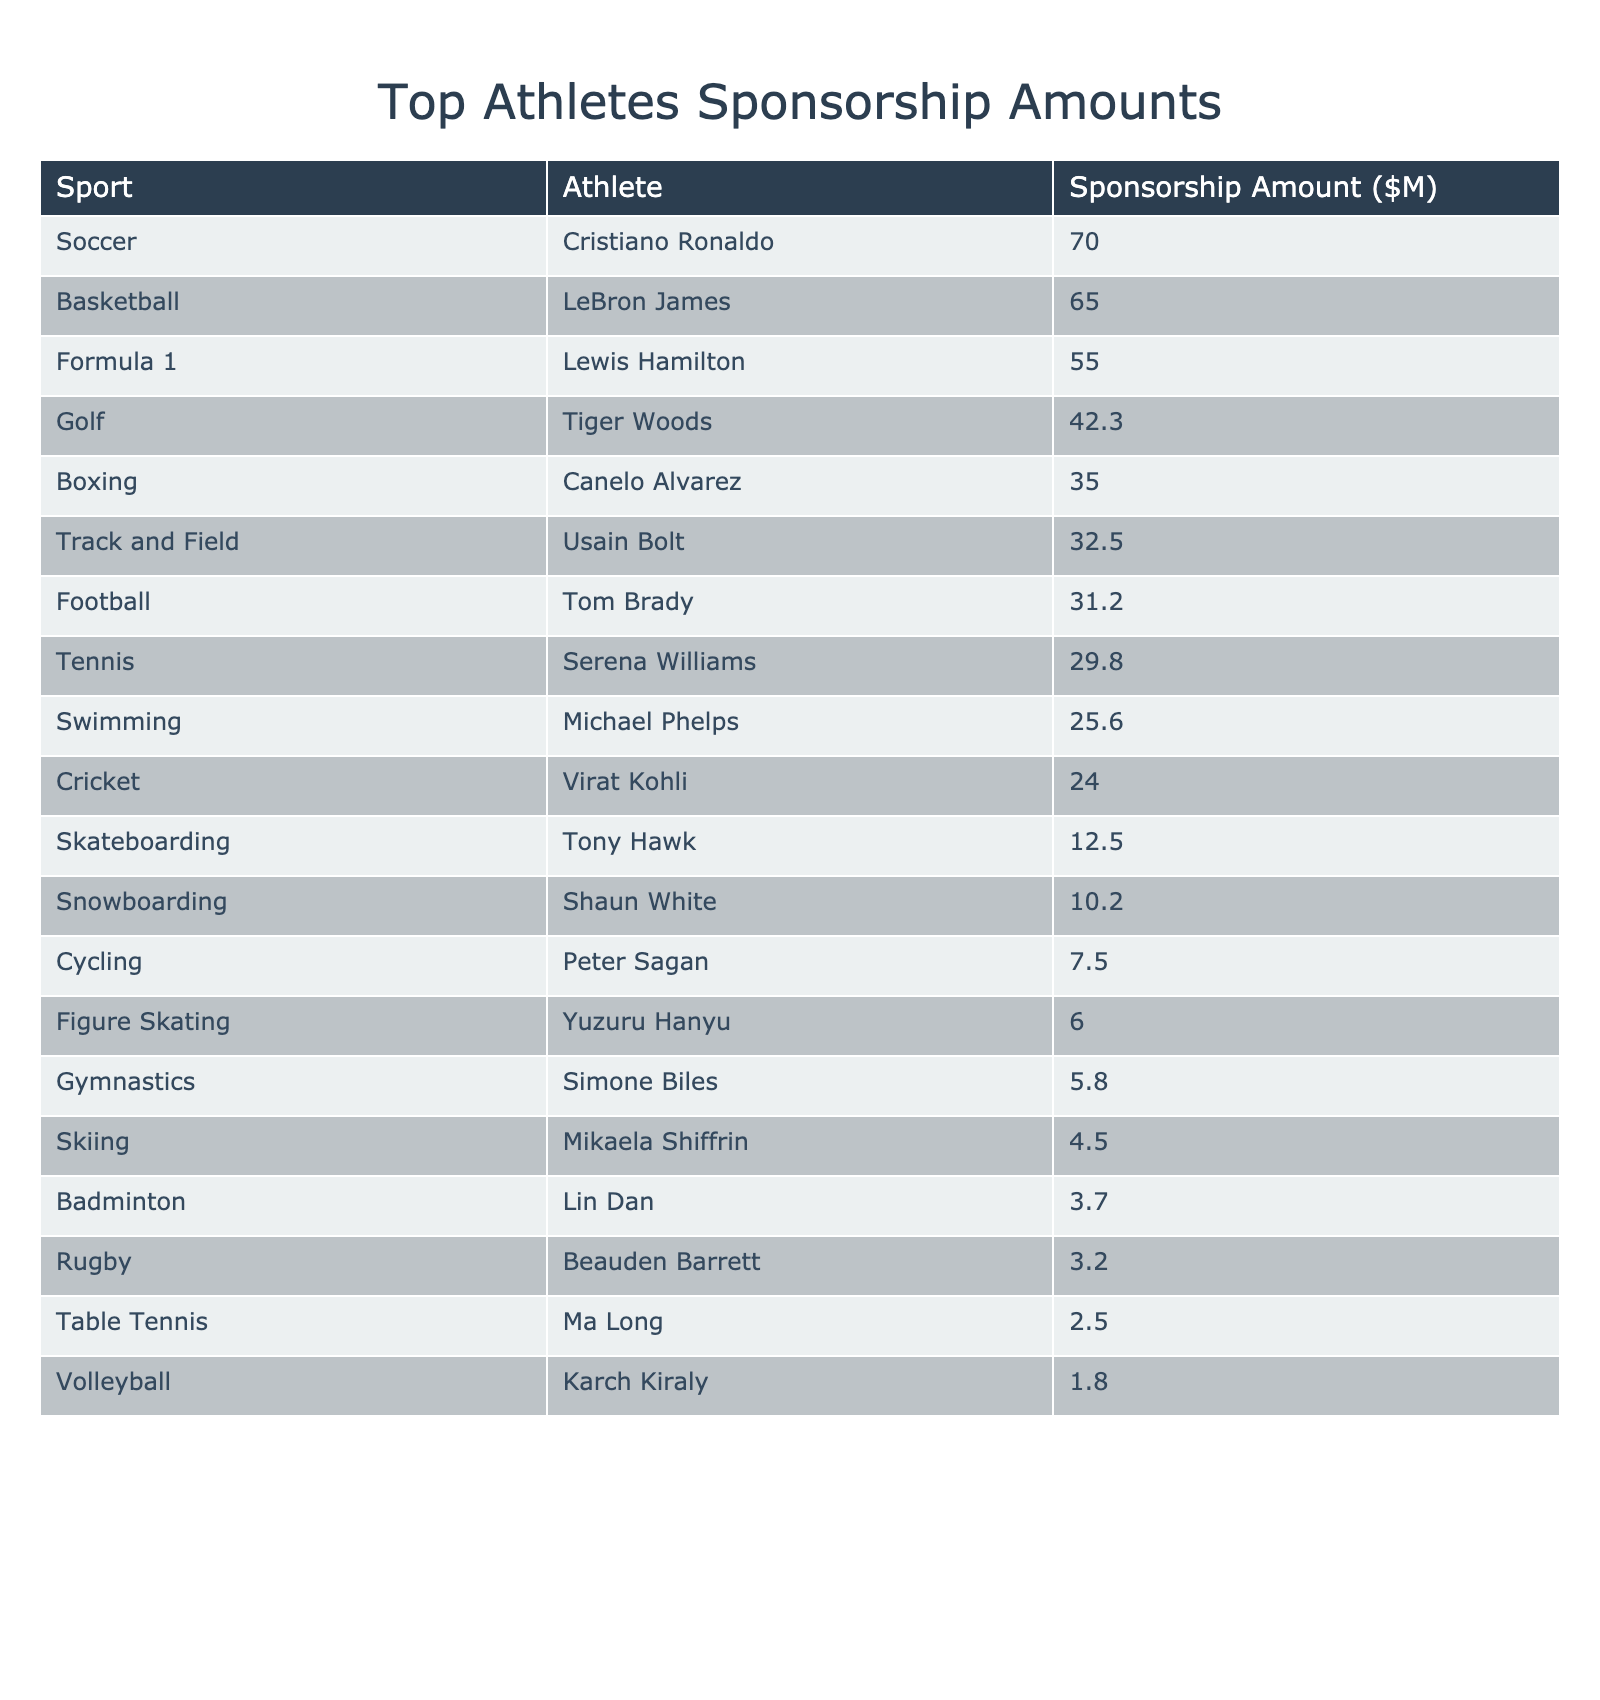What is the highest sponsorship amount among the athletes listed? The table shows that Cristiano Ronaldo has the highest sponsorship amount of $70.0 million.
Answer: 70.0 Which sport does LeBron James represent? LeBron James is listed under the sport of basketball.
Answer: Basketball What is the combined sponsorship amount of all represented soccer and basketball athletes? The sponsorship amount for Cristiano Ronaldo (soccer) is $70.0 million and for LeBron James (basketball) is $65.0 million. The total is 70.0 + 65.0 = $135.0 million.
Answer: 135.0 Is the sponsorship amount for Simone Biles greater than $10 million? The table shows Simone Biles has a sponsorship amount of $5.8 million, which is less than $10 million.
Answer: No What is the average sponsorship amount of the top three athletes? The top three athletes are Cristiano Ronaldo ($70.0M), LeBron James ($65.0M), and Lewis Hamilton ($55.0M). Adding these gives 70.0 + 65.0 + 55.0 = 190.0 million. Dividing by 3 gives an average of 190.0 / 3 = $63.33 million.
Answer: 63.33 How much more does Tiger Woods earn in sponsorship compared to Michael Phelps? Tiger Woods has a sponsorship amount of $42.3 million, while Michael Phelps has $25.6 million. The difference is 42.3 - 25.6 = $16.7 million.
Answer: 16.7 Which sport has the lowest sponsorship amount and how much is it? The table shows that volleyball has the lowest sponsorship amount with Karch Kiraly earning $1.8 million.
Answer: 1.8 If we sum the sponsorship amounts of athletes in individual sports (not team sports), what is the total? The individual sports are golf, tennis, swimming, boxing, gymnastics, figure skating, badminton, skiing, and snowboarding. Their sponsorship amounts are: Tiger Woods ($42.3M) + Serena Williams ($29.8M) + Michael Phelps ($25.6M) + Canelo Alvarez ($35.0M) + Simone Biles ($5.8M) + Yuzuru Hanyu ($6.0M) + Lin Dan ($3.7M) + Mikaela Shiffrin ($4.5M) + Shaun White ($10.2M) = $153.9 million.
Answer: 153.9 How many athletes earn more than $30 million in sponsorship? By checking the table, the athletes earning over $30 million are Cristiano Ronaldo, LeBron James, Tiger Woods, and Lewis Hamilton, totaling four athletes.
Answer: 4 Which athlete earns the least in sponsorship and what is their amount? The analysis of the table reveals that Beauden Barrett, from rugby, earns the least with a sponsorship amount of $3.2 million.
Answer: 3.2 